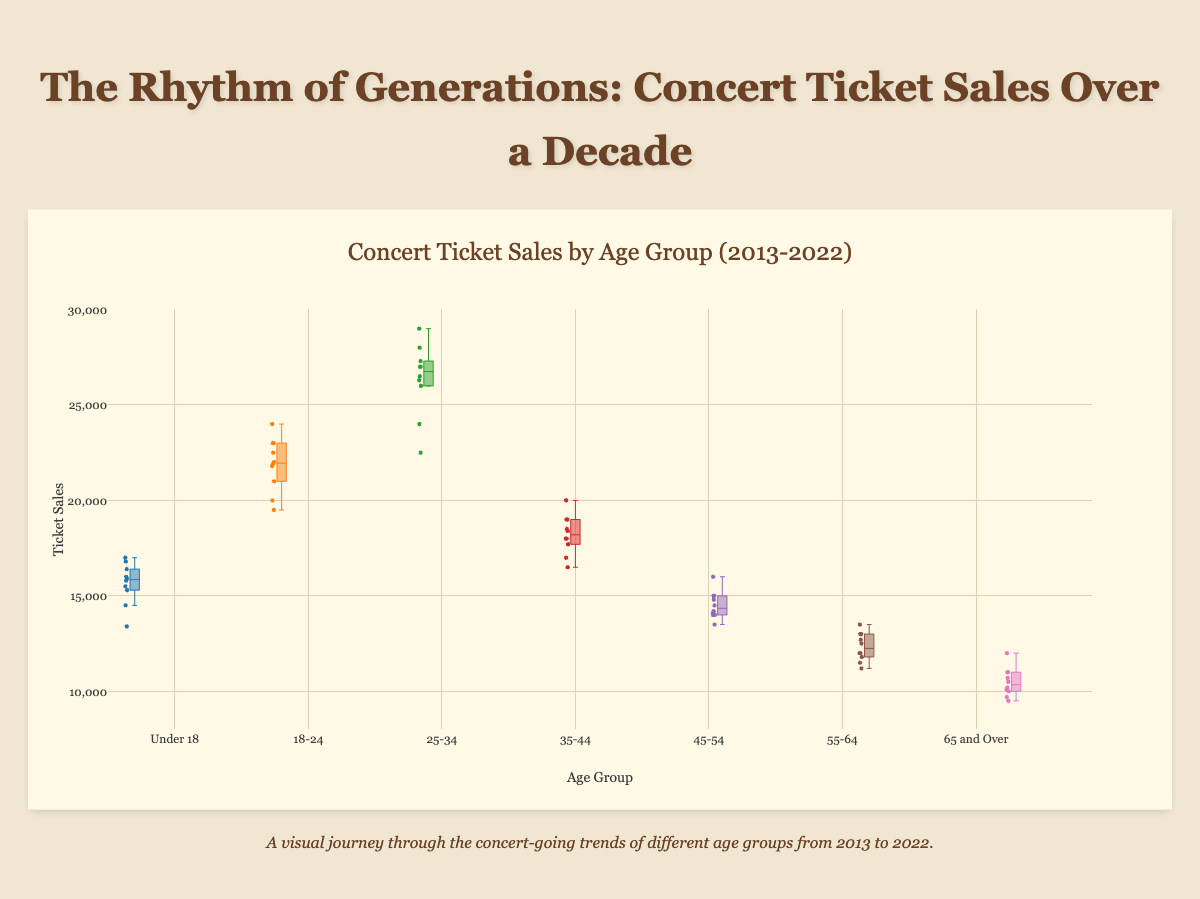What is the title of the chart? The title is displayed prominently at the top of the chart in a larger, bold font. It indicates the overall topic of the visualization.
Answer: Concert Ticket Sales by Age Group (2013-2022) What age group had the highest median ticket sales? Observing the box plots, the median is typically indicated by a line inside the box. The "25-34" age group has the highest median line among all age groups.
Answer: 25-34 Which age group had the lowest range of ticket sales (difference between the maximum and minimum)? The range is represented by the difference between the top whisker and the bottom whisker. The "65 and Over" age group has the smallest distance between its whiskers.
Answer: 65 and Over From which year did ticket sales sharply drop across most age groups? There is a noticeable dip in sales points in most box plots around 2020. This year is likely marked by a line or an outlying dot indicating a drop in sales.
Answer: 2020 Which two age groups have the most similar median ticket sales over the decade? By comparing the medians (lines within the boxes) of each age group, it appears that the "18-24" and "35-44" age groups have closely aligned median values.
Answer: 18-24 and 35-44 What is the approximate range of ticket sales for the "Under 18" age group? The range can be estimated by looking at the span between the maximum and minimum whiskers for this group. The "Under 18" age group's ticket sales span from around 13400 to 17000.
Answer: 13400 to 17000 Which age group shows the highest variability in concert ticket sales? Variability is indicated by the size of the box and the length of the whiskers. The "25-34" age group, with its notably large box and whisker range, shows the highest variability.
Answer: 25-34 How do the ticket sales for the "55-64" age group in 2020 compare to those in 2013? To compare sales, observe the 2020 and 2013 points on the "55-64" box plot. In 2020, sales are around 11200, while in 2013, they are about 12000. So, 2020 sales are slightly lower.
Answer: Lower in 2020 Which age group's ticket sales have consistently increased every year? Examining the trends across the years in each box plot reveals that no age group has a consistent increase in ticket sales every year. Most age groups show fluctuations.
Answer: None What year had the lowest ticket sales overall across all age groups? Looking for the year with the lowest points across all box plots, you will notice 2020 has the lowest individual sales points across almost all age groups.
Answer: 2020 